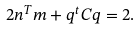Convert formula to latex. <formula><loc_0><loc_0><loc_500><loc_500>2 n ^ { T } m + q ^ { t } C q = 2 .</formula> 